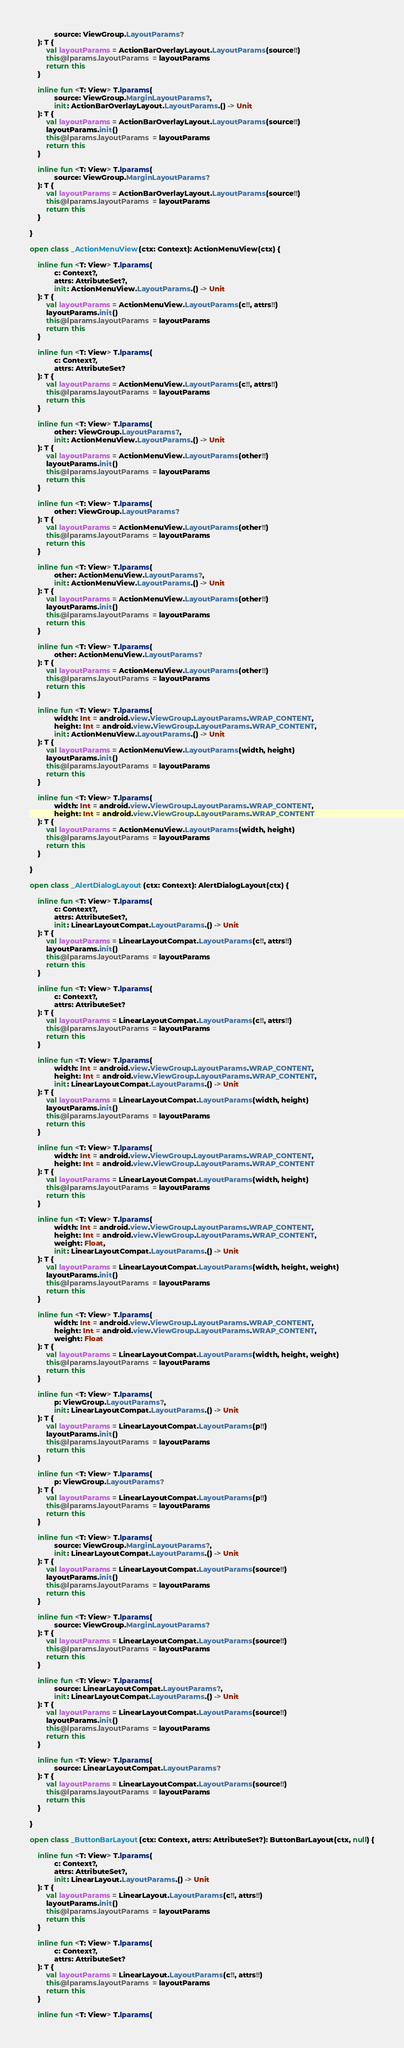<code> <loc_0><loc_0><loc_500><loc_500><_Kotlin_>            source: ViewGroup.LayoutParams?
    ): T {
        val layoutParams = ActionBarOverlayLayout.LayoutParams(source!!)
        this@lparams.layoutParams = layoutParams
        return this
    }

    inline fun <T: View> T.lparams(
            source: ViewGroup.MarginLayoutParams?,
            init: ActionBarOverlayLayout.LayoutParams.() -> Unit
    ): T {
        val layoutParams = ActionBarOverlayLayout.LayoutParams(source!!)
        layoutParams.init()
        this@lparams.layoutParams = layoutParams
        return this
    }

    inline fun <T: View> T.lparams(
            source: ViewGroup.MarginLayoutParams?
    ): T {
        val layoutParams = ActionBarOverlayLayout.LayoutParams(source!!)
        this@lparams.layoutParams = layoutParams
        return this
    }

}

open class _ActionMenuView(ctx: Context): ActionMenuView(ctx) {

    inline fun <T: View> T.lparams(
            c: Context?,
            attrs: AttributeSet?,
            init: ActionMenuView.LayoutParams.() -> Unit
    ): T {
        val layoutParams = ActionMenuView.LayoutParams(c!!, attrs!!)
        layoutParams.init()
        this@lparams.layoutParams = layoutParams
        return this
    }

    inline fun <T: View> T.lparams(
            c: Context?,
            attrs: AttributeSet?
    ): T {
        val layoutParams = ActionMenuView.LayoutParams(c!!, attrs!!)
        this@lparams.layoutParams = layoutParams
        return this
    }

    inline fun <T: View> T.lparams(
            other: ViewGroup.LayoutParams?,
            init: ActionMenuView.LayoutParams.() -> Unit
    ): T {
        val layoutParams = ActionMenuView.LayoutParams(other!!)
        layoutParams.init()
        this@lparams.layoutParams = layoutParams
        return this
    }

    inline fun <T: View> T.lparams(
            other: ViewGroup.LayoutParams?
    ): T {
        val layoutParams = ActionMenuView.LayoutParams(other!!)
        this@lparams.layoutParams = layoutParams
        return this
    }

    inline fun <T: View> T.lparams(
            other: ActionMenuView.LayoutParams?,
            init: ActionMenuView.LayoutParams.() -> Unit
    ): T {
        val layoutParams = ActionMenuView.LayoutParams(other!!)
        layoutParams.init()
        this@lparams.layoutParams = layoutParams
        return this
    }

    inline fun <T: View> T.lparams(
            other: ActionMenuView.LayoutParams?
    ): T {
        val layoutParams = ActionMenuView.LayoutParams(other!!)
        this@lparams.layoutParams = layoutParams
        return this
    }

    inline fun <T: View> T.lparams(
            width: Int = android.view.ViewGroup.LayoutParams.WRAP_CONTENT,
            height: Int = android.view.ViewGroup.LayoutParams.WRAP_CONTENT,
            init: ActionMenuView.LayoutParams.() -> Unit
    ): T {
        val layoutParams = ActionMenuView.LayoutParams(width, height)
        layoutParams.init()
        this@lparams.layoutParams = layoutParams
        return this
    }

    inline fun <T: View> T.lparams(
            width: Int = android.view.ViewGroup.LayoutParams.WRAP_CONTENT,
            height: Int = android.view.ViewGroup.LayoutParams.WRAP_CONTENT
    ): T {
        val layoutParams = ActionMenuView.LayoutParams(width, height)
        this@lparams.layoutParams = layoutParams
        return this
    }

}

open class _AlertDialogLayout(ctx: Context): AlertDialogLayout(ctx) {

    inline fun <T: View> T.lparams(
            c: Context?,
            attrs: AttributeSet?,
            init: LinearLayoutCompat.LayoutParams.() -> Unit
    ): T {
        val layoutParams = LinearLayoutCompat.LayoutParams(c!!, attrs!!)
        layoutParams.init()
        this@lparams.layoutParams = layoutParams
        return this
    }

    inline fun <T: View> T.lparams(
            c: Context?,
            attrs: AttributeSet?
    ): T {
        val layoutParams = LinearLayoutCompat.LayoutParams(c!!, attrs!!)
        this@lparams.layoutParams = layoutParams
        return this
    }

    inline fun <T: View> T.lparams(
            width: Int = android.view.ViewGroup.LayoutParams.WRAP_CONTENT,
            height: Int = android.view.ViewGroup.LayoutParams.WRAP_CONTENT,
            init: LinearLayoutCompat.LayoutParams.() -> Unit
    ): T {
        val layoutParams = LinearLayoutCompat.LayoutParams(width, height)
        layoutParams.init()
        this@lparams.layoutParams = layoutParams
        return this
    }

    inline fun <T: View> T.lparams(
            width: Int = android.view.ViewGroup.LayoutParams.WRAP_CONTENT,
            height: Int = android.view.ViewGroup.LayoutParams.WRAP_CONTENT
    ): T {
        val layoutParams = LinearLayoutCompat.LayoutParams(width, height)
        this@lparams.layoutParams = layoutParams
        return this
    }

    inline fun <T: View> T.lparams(
            width: Int = android.view.ViewGroup.LayoutParams.WRAP_CONTENT,
            height: Int = android.view.ViewGroup.LayoutParams.WRAP_CONTENT,
            weight: Float,
            init: LinearLayoutCompat.LayoutParams.() -> Unit
    ): T {
        val layoutParams = LinearLayoutCompat.LayoutParams(width, height, weight)
        layoutParams.init()
        this@lparams.layoutParams = layoutParams
        return this
    }

    inline fun <T: View> T.lparams(
            width: Int = android.view.ViewGroup.LayoutParams.WRAP_CONTENT,
            height: Int = android.view.ViewGroup.LayoutParams.WRAP_CONTENT,
            weight: Float
    ): T {
        val layoutParams = LinearLayoutCompat.LayoutParams(width, height, weight)
        this@lparams.layoutParams = layoutParams
        return this
    }

    inline fun <T: View> T.lparams(
            p: ViewGroup.LayoutParams?,
            init: LinearLayoutCompat.LayoutParams.() -> Unit
    ): T {
        val layoutParams = LinearLayoutCompat.LayoutParams(p!!)
        layoutParams.init()
        this@lparams.layoutParams = layoutParams
        return this
    }

    inline fun <T: View> T.lparams(
            p: ViewGroup.LayoutParams?
    ): T {
        val layoutParams = LinearLayoutCompat.LayoutParams(p!!)
        this@lparams.layoutParams = layoutParams
        return this
    }

    inline fun <T: View> T.lparams(
            source: ViewGroup.MarginLayoutParams?,
            init: LinearLayoutCompat.LayoutParams.() -> Unit
    ): T {
        val layoutParams = LinearLayoutCompat.LayoutParams(source!!)
        layoutParams.init()
        this@lparams.layoutParams = layoutParams
        return this
    }

    inline fun <T: View> T.lparams(
            source: ViewGroup.MarginLayoutParams?
    ): T {
        val layoutParams = LinearLayoutCompat.LayoutParams(source!!)
        this@lparams.layoutParams = layoutParams
        return this
    }

    inline fun <T: View> T.lparams(
            source: LinearLayoutCompat.LayoutParams?,
            init: LinearLayoutCompat.LayoutParams.() -> Unit
    ): T {
        val layoutParams = LinearLayoutCompat.LayoutParams(source!!)
        layoutParams.init()
        this@lparams.layoutParams = layoutParams
        return this
    }

    inline fun <T: View> T.lparams(
            source: LinearLayoutCompat.LayoutParams?
    ): T {
        val layoutParams = LinearLayoutCompat.LayoutParams(source!!)
        this@lparams.layoutParams = layoutParams
        return this
    }

}

open class _ButtonBarLayout(ctx: Context, attrs: AttributeSet?): ButtonBarLayout(ctx, null) {

    inline fun <T: View> T.lparams(
            c: Context?,
            attrs: AttributeSet?,
            init: LinearLayout.LayoutParams.() -> Unit
    ): T {
        val layoutParams = LinearLayout.LayoutParams(c!!, attrs!!)
        layoutParams.init()
        this@lparams.layoutParams = layoutParams
        return this
    }

    inline fun <T: View> T.lparams(
            c: Context?,
            attrs: AttributeSet?
    ): T {
        val layoutParams = LinearLayout.LayoutParams(c!!, attrs!!)
        this@lparams.layoutParams = layoutParams
        return this
    }

    inline fun <T: View> T.lparams(</code> 